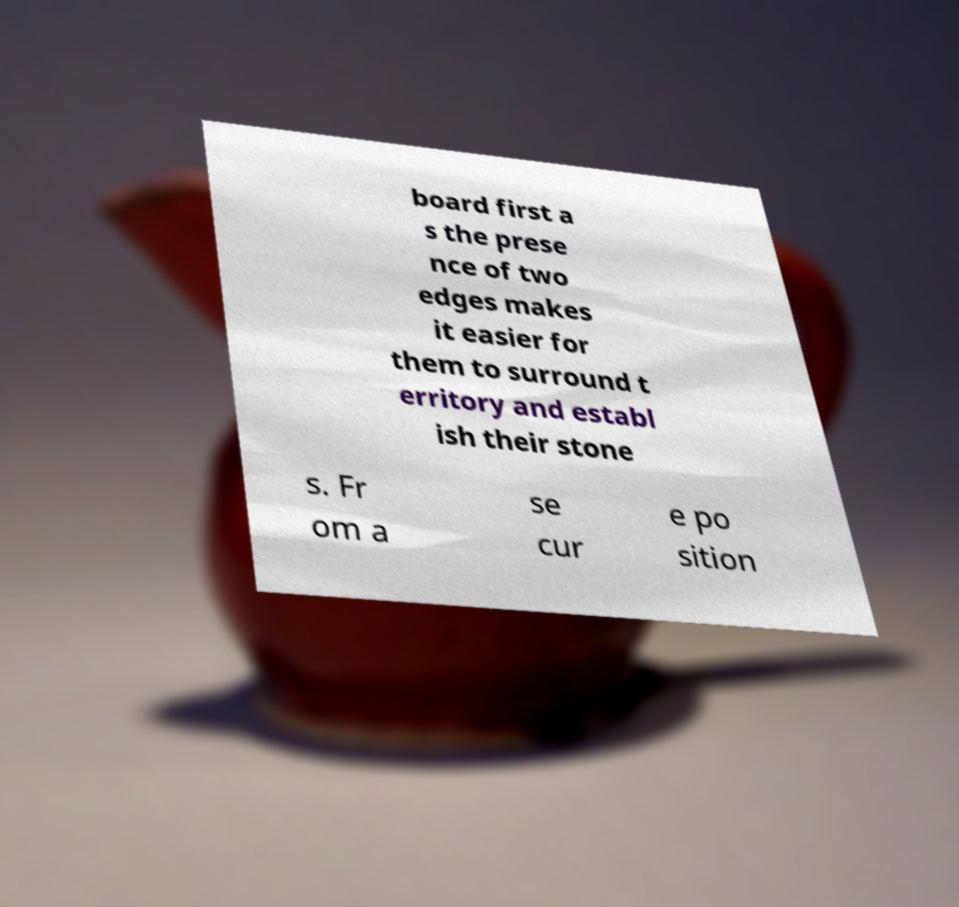Please identify and transcribe the text found in this image. board first a s the prese nce of two edges makes it easier for them to surround t erritory and establ ish their stone s. Fr om a se cur e po sition 